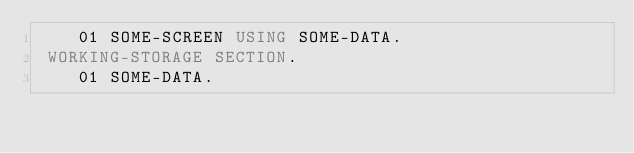<code> <loc_0><loc_0><loc_500><loc_500><_COBOL_>    01 SOME-SCREEN USING SOME-DATA.
 WORKING-STORAGE SECTION.
    01 SOME-DATA.</code> 